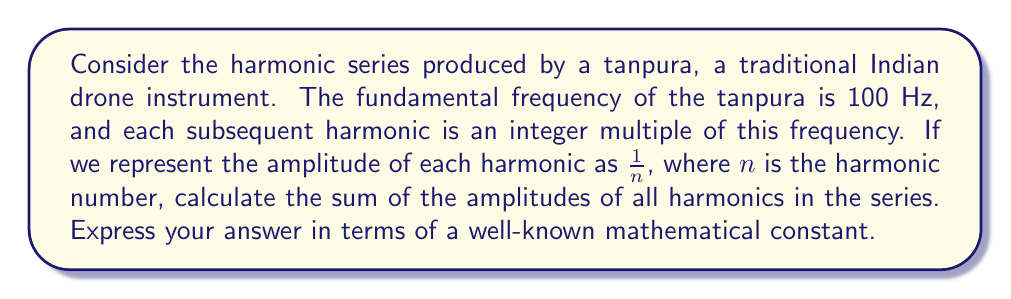Can you answer this question? To solve this problem, we need to analyze the infinite series representing the amplitudes of the harmonics:

$$S = 1 + \frac{1}{2} + \frac{1}{3} + \frac{1}{4} + \frac{1}{5} + \cdots$$

This series is known as the harmonic series, which is divergent. However, we can relate it to a well-known mathematical constant.

1) First, let's consider the natural logarithm series:

   $$\ln(1+x) = x - \frac{x^2}{2} + \frac{x^3}{3} - \frac{x^4}{4} + \frac{x^5}{5} - \cdots$$

2) If we substitute $x=1$ into this series, we get:

   $$\ln(2) = 1 - \frac{1}{2} + \frac{1}{3} - \frac{1}{4} + \frac{1}{5} - \cdots$$

3) Now, let's multiply both sides by -1:

   $$-\ln(2) = -1 + \frac{1}{2} - \frac{1}{3} + \frac{1}{4} - \frac{1}{5} + \cdots$$

4) Adding this to our original harmonic series:

   $$S - \ln(2) = (1 + \frac{1}{2} + \frac{1}{3} + \frac{1}{4} + \frac{1}{5} + \cdots) + (-1 + \frac{1}{2} - \frac{1}{3} + \frac{1}{4} - \frac{1}{5} + \cdots)$$

5) Simplifying the right side:

   $$S - \ln(2) = (1 + \frac{1}{2} + \frac{1}{3} + \frac{1}{4} + \frac{1}{5} + \cdots) + (-1 + \frac{1}{2} - \frac{1}{3} + \frac{1}{4} - \frac{1}{5} + \cdots)$$
   $$= (1 + 1) + (\frac{1}{2} + \frac{1}{2}) + (0) + (\frac{1}{4} + \frac{1}{4}) + (0) + \cdots$$
   $$= 2 + 1 + 0 + \frac{1}{2} + 0 + \cdots$$
   $$= 3$$

6) Therefore:

   $$S - \ln(2) = 3$$
   $$S = 3 + \ln(2)$$

This is the sum of the amplitudes of all harmonics in the series, expressed in terms of the natural logarithm of 2.
Answer: $3 + \ln(2)$ 